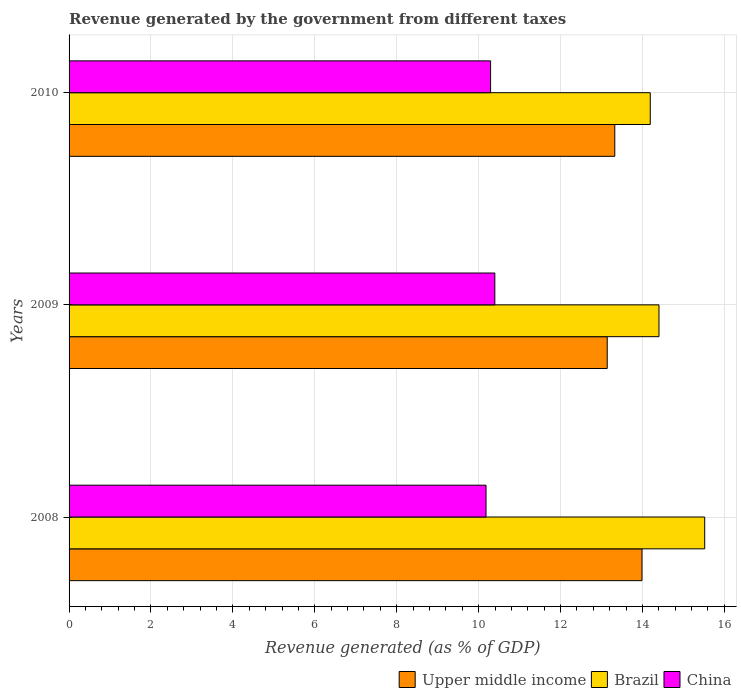How many groups of bars are there?
Make the answer very short. 3. How many bars are there on the 1st tick from the top?
Your answer should be very brief. 3. What is the label of the 2nd group of bars from the top?
Provide a succinct answer. 2009. In how many cases, is the number of bars for a given year not equal to the number of legend labels?
Your answer should be very brief. 0. What is the revenue generated by the government in Brazil in 2009?
Ensure brevity in your answer.  14.4. Across all years, what is the maximum revenue generated by the government in China?
Your answer should be compact. 10.4. Across all years, what is the minimum revenue generated by the government in Upper middle income?
Provide a short and direct response. 13.14. In which year was the revenue generated by the government in Upper middle income maximum?
Your answer should be compact. 2008. What is the total revenue generated by the government in Brazil in the graph?
Provide a succinct answer. 44.12. What is the difference between the revenue generated by the government in China in 2008 and that in 2009?
Give a very brief answer. -0.21. What is the difference between the revenue generated by the government in China in 2009 and the revenue generated by the government in Brazil in 2008?
Your answer should be compact. -5.12. What is the average revenue generated by the government in Brazil per year?
Your answer should be very brief. 14.71. In the year 2009, what is the difference between the revenue generated by the government in Upper middle income and revenue generated by the government in China?
Your response must be concise. 2.74. What is the ratio of the revenue generated by the government in Brazil in 2008 to that in 2010?
Provide a succinct answer. 1.09. What is the difference between the highest and the second highest revenue generated by the government in Brazil?
Give a very brief answer. 1.12. What is the difference between the highest and the lowest revenue generated by the government in China?
Keep it short and to the point. 0.21. Is the sum of the revenue generated by the government in China in 2009 and 2010 greater than the maximum revenue generated by the government in Upper middle income across all years?
Offer a terse response. Yes. What does the 1st bar from the bottom in 2010 represents?
Offer a terse response. Upper middle income. Is it the case that in every year, the sum of the revenue generated by the government in Brazil and revenue generated by the government in China is greater than the revenue generated by the government in Upper middle income?
Offer a very short reply. Yes. Are all the bars in the graph horizontal?
Make the answer very short. Yes. What is the difference between two consecutive major ticks on the X-axis?
Your answer should be compact. 2. Does the graph contain grids?
Make the answer very short. Yes. What is the title of the graph?
Your response must be concise. Revenue generated by the government from different taxes. What is the label or title of the X-axis?
Offer a terse response. Revenue generated (as % of GDP). What is the label or title of the Y-axis?
Keep it short and to the point. Years. What is the Revenue generated (as % of GDP) of Upper middle income in 2008?
Provide a short and direct response. 13.99. What is the Revenue generated (as % of GDP) of Brazil in 2008?
Your answer should be very brief. 15.52. What is the Revenue generated (as % of GDP) of China in 2008?
Provide a succinct answer. 10.18. What is the Revenue generated (as % of GDP) in Upper middle income in 2009?
Your response must be concise. 13.14. What is the Revenue generated (as % of GDP) in Brazil in 2009?
Give a very brief answer. 14.4. What is the Revenue generated (as % of GDP) in China in 2009?
Offer a terse response. 10.4. What is the Revenue generated (as % of GDP) in Upper middle income in 2010?
Give a very brief answer. 13.32. What is the Revenue generated (as % of GDP) of Brazil in 2010?
Provide a succinct answer. 14.19. What is the Revenue generated (as % of GDP) of China in 2010?
Provide a succinct answer. 10.29. Across all years, what is the maximum Revenue generated (as % of GDP) in Upper middle income?
Offer a very short reply. 13.99. Across all years, what is the maximum Revenue generated (as % of GDP) in Brazil?
Your answer should be compact. 15.52. Across all years, what is the maximum Revenue generated (as % of GDP) of China?
Provide a short and direct response. 10.4. Across all years, what is the minimum Revenue generated (as % of GDP) of Upper middle income?
Give a very brief answer. 13.14. Across all years, what is the minimum Revenue generated (as % of GDP) of Brazil?
Your answer should be compact. 14.19. Across all years, what is the minimum Revenue generated (as % of GDP) of China?
Give a very brief answer. 10.18. What is the total Revenue generated (as % of GDP) of Upper middle income in the graph?
Your response must be concise. 40.45. What is the total Revenue generated (as % of GDP) of Brazil in the graph?
Provide a succinct answer. 44.12. What is the total Revenue generated (as % of GDP) in China in the graph?
Make the answer very short. 30.87. What is the difference between the Revenue generated (as % of GDP) of Upper middle income in 2008 and that in 2009?
Ensure brevity in your answer.  0.85. What is the difference between the Revenue generated (as % of GDP) in Brazil in 2008 and that in 2009?
Offer a very short reply. 1.12. What is the difference between the Revenue generated (as % of GDP) of China in 2008 and that in 2009?
Provide a short and direct response. -0.21. What is the difference between the Revenue generated (as % of GDP) of Upper middle income in 2008 and that in 2010?
Provide a short and direct response. 0.66. What is the difference between the Revenue generated (as % of GDP) of Brazil in 2008 and that in 2010?
Your response must be concise. 1.33. What is the difference between the Revenue generated (as % of GDP) in China in 2008 and that in 2010?
Make the answer very short. -0.11. What is the difference between the Revenue generated (as % of GDP) in Upper middle income in 2009 and that in 2010?
Provide a succinct answer. -0.18. What is the difference between the Revenue generated (as % of GDP) in Brazil in 2009 and that in 2010?
Ensure brevity in your answer.  0.21. What is the difference between the Revenue generated (as % of GDP) of China in 2009 and that in 2010?
Your answer should be very brief. 0.1. What is the difference between the Revenue generated (as % of GDP) in Upper middle income in 2008 and the Revenue generated (as % of GDP) in Brazil in 2009?
Keep it short and to the point. -0.41. What is the difference between the Revenue generated (as % of GDP) in Upper middle income in 2008 and the Revenue generated (as % of GDP) in China in 2009?
Keep it short and to the point. 3.59. What is the difference between the Revenue generated (as % of GDP) in Brazil in 2008 and the Revenue generated (as % of GDP) in China in 2009?
Your answer should be compact. 5.12. What is the difference between the Revenue generated (as % of GDP) of Upper middle income in 2008 and the Revenue generated (as % of GDP) of Brazil in 2010?
Offer a terse response. -0.2. What is the difference between the Revenue generated (as % of GDP) of Upper middle income in 2008 and the Revenue generated (as % of GDP) of China in 2010?
Your response must be concise. 3.7. What is the difference between the Revenue generated (as % of GDP) of Brazil in 2008 and the Revenue generated (as % of GDP) of China in 2010?
Provide a succinct answer. 5.23. What is the difference between the Revenue generated (as % of GDP) of Upper middle income in 2009 and the Revenue generated (as % of GDP) of Brazil in 2010?
Make the answer very short. -1.05. What is the difference between the Revenue generated (as % of GDP) of Upper middle income in 2009 and the Revenue generated (as % of GDP) of China in 2010?
Give a very brief answer. 2.85. What is the difference between the Revenue generated (as % of GDP) in Brazil in 2009 and the Revenue generated (as % of GDP) in China in 2010?
Keep it short and to the point. 4.11. What is the average Revenue generated (as % of GDP) in Upper middle income per year?
Give a very brief answer. 13.48. What is the average Revenue generated (as % of GDP) of Brazil per year?
Ensure brevity in your answer.  14.71. What is the average Revenue generated (as % of GDP) of China per year?
Your response must be concise. 10.29. In the year 2008, what is the difference between the Revenue generated (as % of GDP) in Upper middle income and Revenue generated (as % of GDP) in Brazil?
Offer a terse response. -1.53. In the year 2008, what is the difference between the Revenue generated (as % of GDP) in Upper middle income and Revenue generated (as % of GDP) in China?
Keep it short and to the point. 3.81. In the year 2008, what is the difference between the Revenue generated (as % of GDP) of Brazil and Revenue generated (as % of GDP) of China?
Provide a short and direct response. 5.34. In the year 2009, what is the difference between the Revenue generated (as % of GDP) in Upper middle income and Revenue generated (as % of GDP) in Brazil?
Keep it short and to the point. -1.26. In the year 2009, what is the difference between the Revenue generated (as % of GDP) of Upper middle income and Revenue generated (as % of GDP) of China?
Give a very brief answer. 2.74. In the year 2009, what is the difference between the Revenue generated (as % of GDP) of Brazil and Revenue generated (as % of GDP) of China?
Keep it short and to the point. 4.01. In the year 2010, what is the difference between the Revenue generated (as % of GDP) of Upper middle income and Revenue generated (as % of GDP) of Brazil?
Offer a very short reply. -0.87. In the year 2010, what is the difference between the Revenue generated (as % of GDP) in Upper middle income and Revenue generated (as % of GDP) in China?
Keep it short and to the point. 3.03. In the year 2010, what is the difference between the Revenue generated (as % of GDP) in Brazil and Revenue generated (as % of GDP) in China?
Offer a very short reply. 3.9. What is the ratio of the Revenue generated (as % of GDP) of Upper middle income in 2008 to that in 2009?
Keep it short and to the point. 1.06. What is the ratio of the Revenue generated (as % of GDP) in Brazil in 2008 to that in 2009?
Offer a very short reply. 1.08. What is the ratio of the Revenue generated (as % of GDP) in China in 2008 to that in 2009?
Provide a short and direct response. 0.98. What is the ratio of the Revenue generated (as % of GDP) in Upper middle income in 2008 to that in 2010?
Make the answer very short. 1.05. What is the ratio of the Revenue generated (as % of GDP) of Brazil in 2008 to that in 2010?
Give a very brief answer. 1.09. What is the ratio of the Revenue generated (as % of GDP) in China in 2008 to that in 2010?
Offer a terse response. 0.99. What is the ratio of the Revenue generated (as % of GDP) in Upper middle income in 2009 to that in 2010?
Your answer should be compact. 0.99. What is the ratio of the Revenue generated (as % of GDP) in Brazil in 2009 to that in 2010?
Provide a short and direct response. 1.01. What is the difference between the highest and the second highest Revenue generated (as % of GDP) in Upper middle income?
Provide a succinct answer. 0.66. What is the difference between the highest and the second highest Revenue generated (as % of GDP) in Brazil?
Give a very brief answer. 1.12. What is the difference between the highest and the second highest Revenue generated (as % of GDP) in China?
Your answer should be compact. 0.1. What is the difference between the highest and the lowest Revenue generated (as % of GDP) of Upper middle income?
Keep it short and to the point. 0.85. What is the difference between the highest and the lowest Revenue generated (as % of GDP) of Brazil?
Offer a very short reply. 1.33. What is the difference between the highest and the lowest Revenue generated (as % of GDP) in China?
Keep it short and to the point. 0.21. 